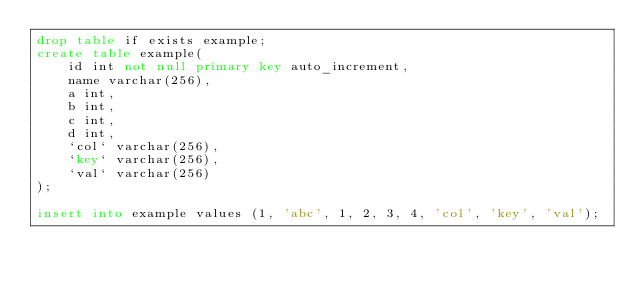<code> <loc_0><loc_0><loc_500><loc_500><_SQL_>drop table if exists example;
create table example(
    id int not null primary key auto_increment,
    name varchar(256),
    a int,
    b int,
    c int,
    d int,
    `col` varchar(256),
    `key` varchar(256),
    `val` varchar(256)
);

insert into example values (1, 'abc', 1, 2, 3, 4, 'col', 'key', 'val');
</code> 